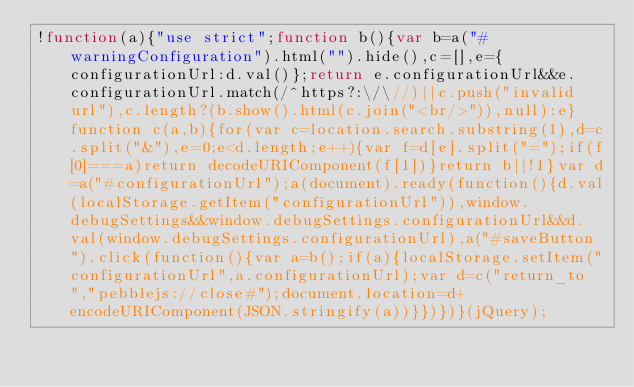Convert code to text. <code><loc_0><loc_0><loc_500><loc_500><_JavaScript_>!function(a){"use strict";function b(){var b=a("#warningConfiguration").html("").hide(),c=[],e={configurationUrl:d.val()};return e.configurationUrl&&e.configurationUrl.match(/^https?:\/\//)||c.push("invalid url"),c.length?(b.show().html(c.join("<br/>")),null):e}function c(a,b){for(var c=location.search.substring(1),d=c.split("&"),e=0;e<d.length;e++){var f=d[e].split("=");if(f[0]===a)return decodeURIComponent(f[1])}return b||!1}var d=a("#configurationUrl");a(document).ready(function(){d.val(localStorage.getItem("configurationUrl")),window.debugSettings&&window.debugSettings.configurationUrl&&d.val(window.debugSettings.configurationUrl),a("#saveButton").click(function(){var a=b();if(a){localStorage.setItem("configurationUrl",a.configurationUrl);var d=c("return_to","pebblejs://close#");document.location=d+encodeURIComponent(JSON.stringify(a))}})})}(jQuery);</code> 